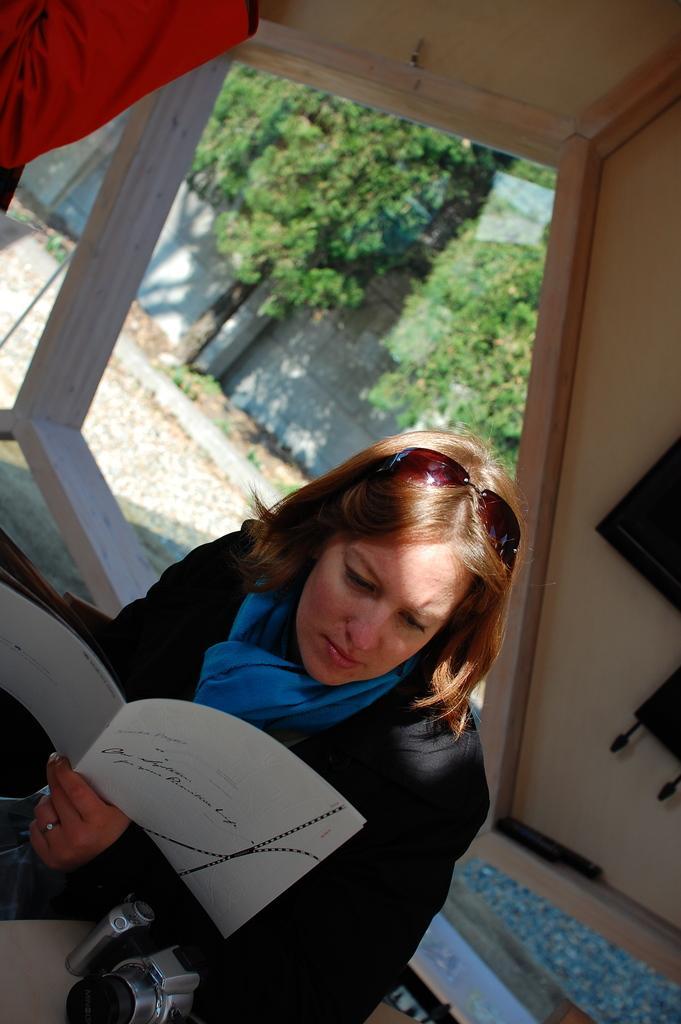Please provide a concise description of this image. In this image I can see the person with the dress and holding the paper. I can see the person is under the shed. I can see some objects to the wall. In the background I can see many trees and the wall. 